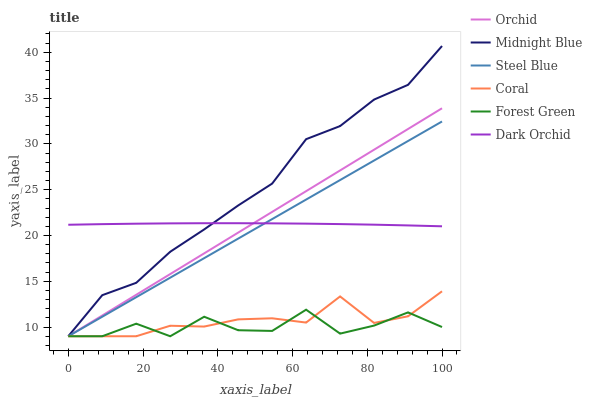Does Coral have the minimum area under the curve?
Answer yes or no. No. Does Coral have the maximum area under the curve?
Answer yes or no. No. Is Coral the smoothest?
Answer yes or no. No. Is Coral the roughest?
Answer yes or no. No. Does Dark Orchid have the lowest value?
Answer yes or no. No. Does Coral have the highest value?
Answer yes or no. No. Is Coral less than Dark Orchid?
Answer yes or no. Yes. Is Dark Orchid greater than Coral?
Answer yes or no. Yes. Does Coral intersect Dark Orchid?
Answer yes or no. No. 